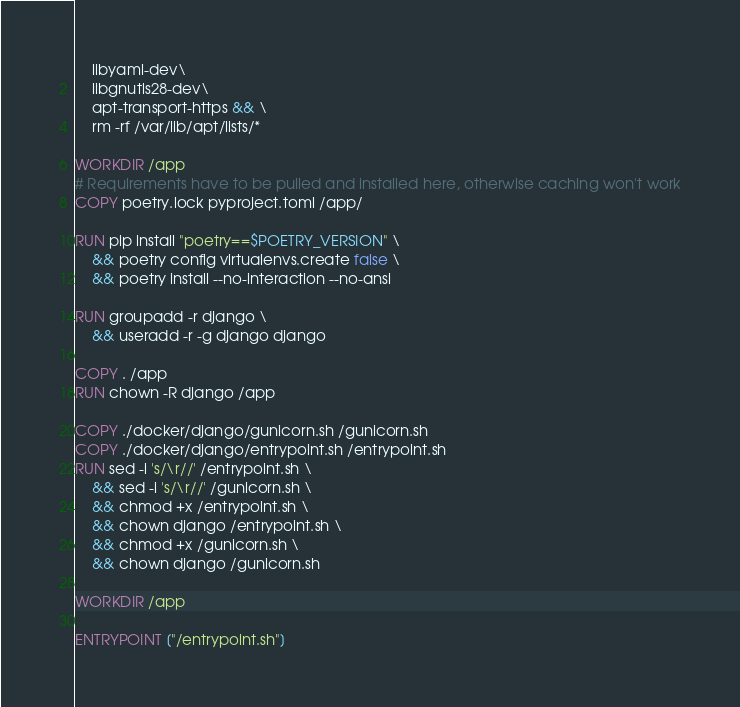<code> <loc_0><loc_0><loc_500><loc_500><_Dockerfile_>    libyaml-dev\
    libgnutls28-dev\
    apt-transport-https && \
    rm -rf /var/lib/apt/lists/*

WORKDIR /app
# Requirements have to be pulled and installed here, otherwise caching won't work
COPY poetry.lock pyproject.toml /app/

RUN pip install "poetry==$POETRY_VERSION" \
    && poetry config virtualenvs.create false \
    && poetry install --no-interaction --no-ansi

RUN groupadd -r django \
    && useradd -r -g django django

COPY . /app
RUN chown -R django /app

COPY ./docker/django/gunicorn.sh /gunicorn.sh
COPY ./docker/django/entrypoint.sh /entrypoint.sh
RUN sed -i 's/\r//' /entrypoint.sh \
    && sed -i 's/\r//' /gunicorn.sh \
    && chmod +x /entrypoint.sh \
    && chown django /entrypoint.sh \
    && chmod +x /gunicorn.sh \
    && chown django /gunicorn.sh

WORKDIR /app

ENTRYPOINT ["/entrypoint.sh"]
</code> 